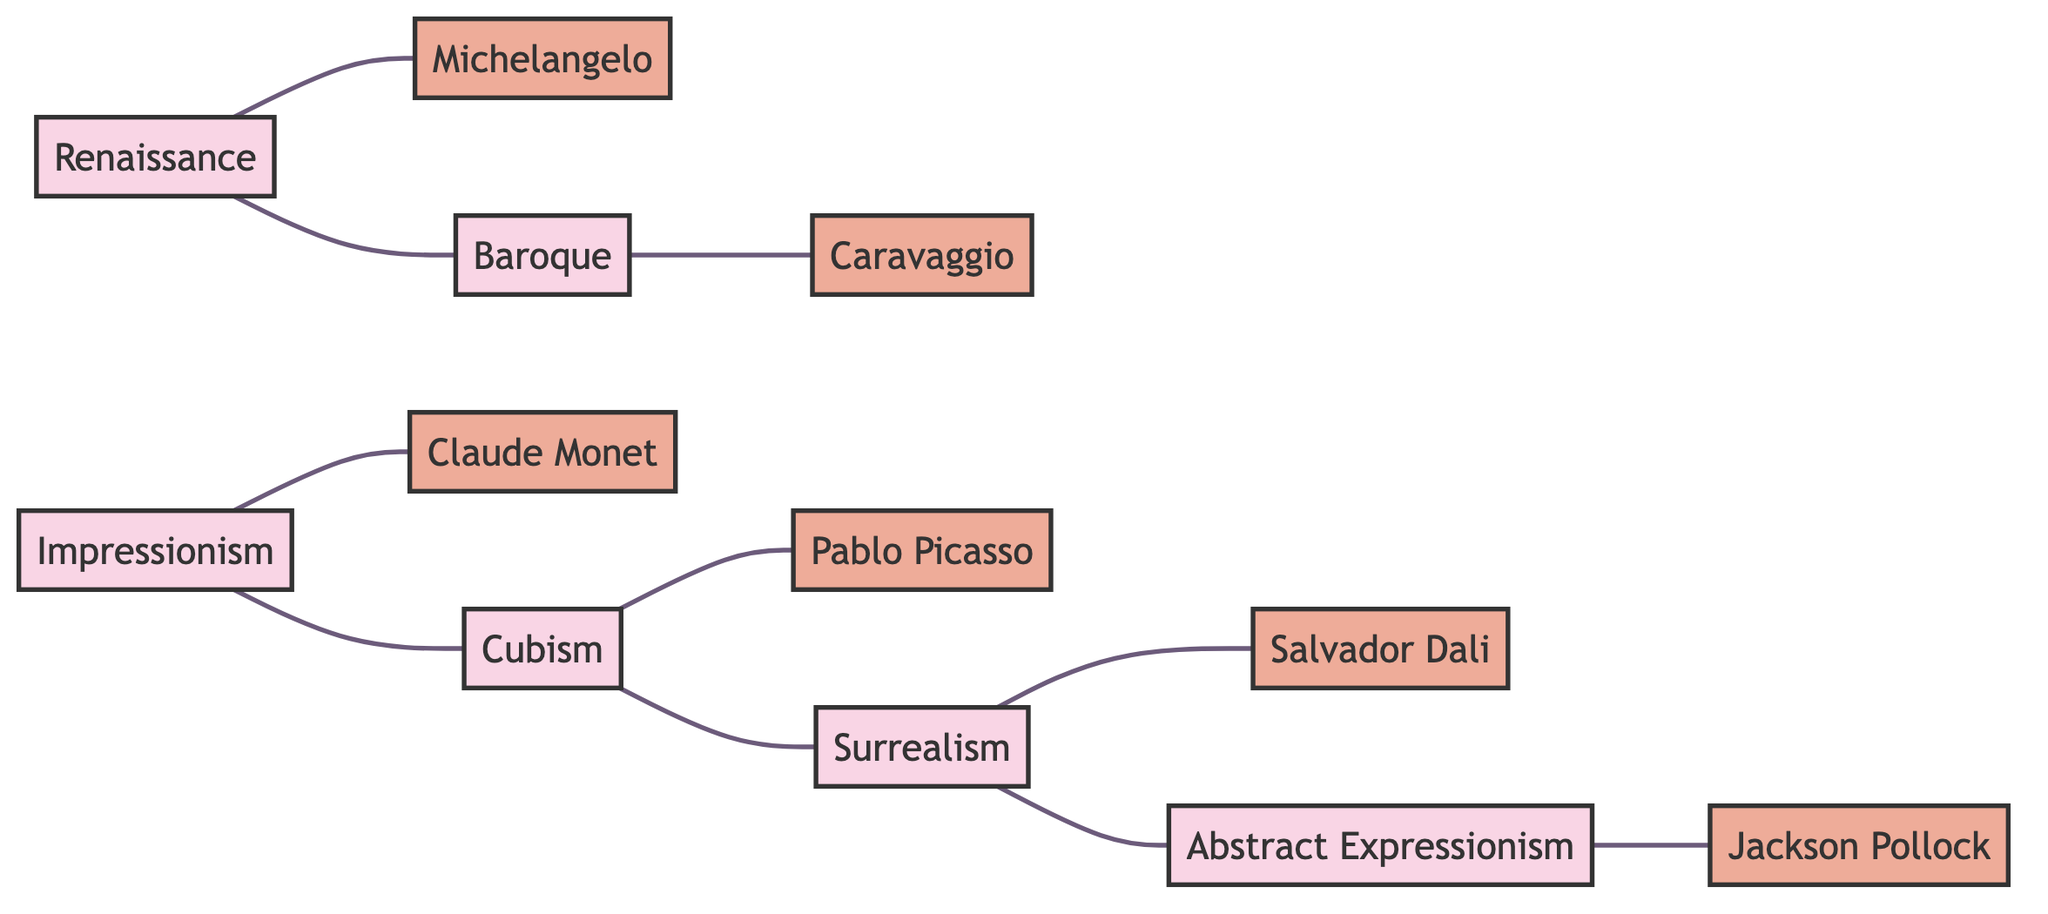What are the visual art movements represented in the diagram? The nodes in the diagram depict various art movements, including Renaissance, Baroque, Impressionism, Cubism, Surrealism, and Abstract Expressionism.
Answer: Renaissance, Baroque, Impressionism, Cubism, Surrealism, Abstract Expressionism Who is linked to the Baroque movement? The diagram shows an edge connecting the Baroque movement to Caravaggio, indicating that he is associated with it.
Answer: Caravaggio How many artists are represented in the diagram? By counting the artist nodes, we find that there are six artists: Michelangelo, Caravaggio, Claude Monet, Pablo Picasso, Salvador Dali, and Jackson Pollock.
Answer: 6 Which art movement is directly linked to both Impressionism and Cubism? The diagram shows that Impressionism is linked to Cubism. Thus, it can be inferred that Impressionism is the art movement directly connecting to Cubism.
Answer: Impressionism What is the total number of edges in the diagram? By counting the connections (edges) that link the nodes (both artists and movements), the diagram consists of six direct connections between movements and artists, plus four additional connections between movements, resulting in a total of ten edges.
Answer: 10 Which movements are connected to Surrealism? The diagram depicts two edges: one connects Surrealism to Cubism and the other connects it to Abstract Expressionism, demonstrating its links to both movements.
Answer: Cubism, Abstract Expressionism How many art movements are directly connected to Renaissance? The diagram reveals that Renaissance is connected to Baroque and Michelangelo, showing that a total of two nodes are linked directly to it.
Answer: 2 What is the sequence of movements from Cubism to Abstract Expressionism as depicted in the diagram? The diagram shows a connection from Cubism to Surrealism, followed by a connection from Surrealism to Abstract Expressionism, forming a sequence of movements.
Answer: Cubism, Surrealism, Abstract Expressionism 